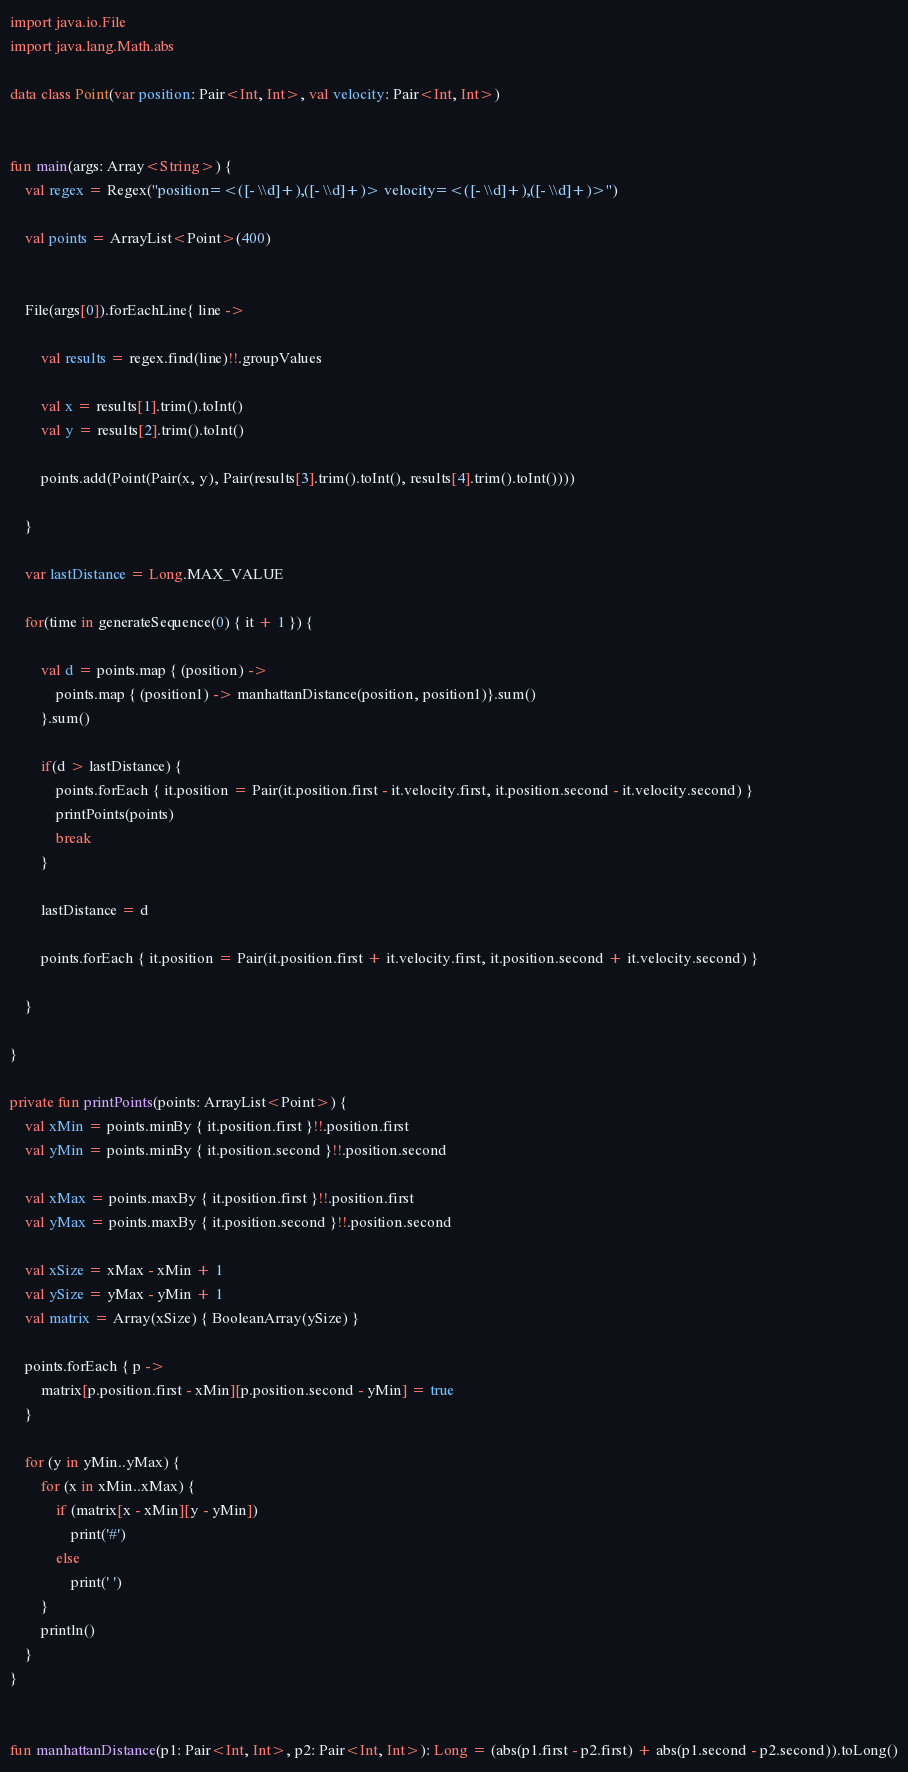<code> <loc_0><loc_0><loc_500><loc_500><_Kotlin_>import java.io.File
import java.lang.Math.abs

data class Point(var position: Pair<Int, Int>, val velocity: Pair<Int, Int>)


fun main(args: Array<String>) {
    val regex = Regex("position=<([- \\d]+),([- \\d]+)> velocity=<([- \\d]+),([- \\d]+)>")

    val points = ArrayList<Point>(400)


    File(args[0]).forEachLine{ line ->

        val results = regex.find(line)!!.groupValues

        val x = results[1].trim().toInt()
        val y = results[2].trim().toInt()

        points.add(Point(Pair(x, y), Pair(results[3].trim().toInt(), results[4].trim().toInt())))

    }

    var lastDistance = Long.MAX_VALUE

    for(time in generateSequence(0) { it + 1 }) {

        val d = points.map { (position) ->
            points.map { (position1) -> manhattanDistance(position, position1)}.sum()
        }.sum()

        if(d > lastDistance) {
            points.forEach { it.position = Pair(it.position.first - it.velocity.first, it.position.second - it.velocity.second) }
            printPoints(points)
            break
        }

        lastDistance = d

        points.forEach { it.position = Pair(it.position.first + it.velocity.first, it.position.second + it.velocity.second) }

    }
    
}

private fun printPoints(points: ArrayList<Point>) {
    val xMin = points.minBy { it.position.first }!!.position.first
    val yMin = points.minBy { it.position.second }!!.position.second

    val xMax = points.maxBy { it.position.first }!!.position.first
    val yMax = points.maxBy { it.position.second }!!.position.second

    val xSize = xMax - xMin + 1
    val ySize = yMax - yMin + 1
    val matrix = Array(xSize) { BooleanArray(ySize) }

    points.forEach { p ->
        matrix[p.position.first - xMin][p.position.second - yMin] = true
    }

    for (y in yMin..yMax) {
        for (x in xMin..xMax) {
            if (matrix[x - xMin][y - yMin])
                print('#')
            else
                print(' ')
        }
        println()
    }
}


fun manhattanDistance(p1: Pair<Int, Int>, p2: Pair<Int, Int>): Long = (abs(p1.first - p2.first) + abs(p1.second - p2.second)).toLong()</code> 